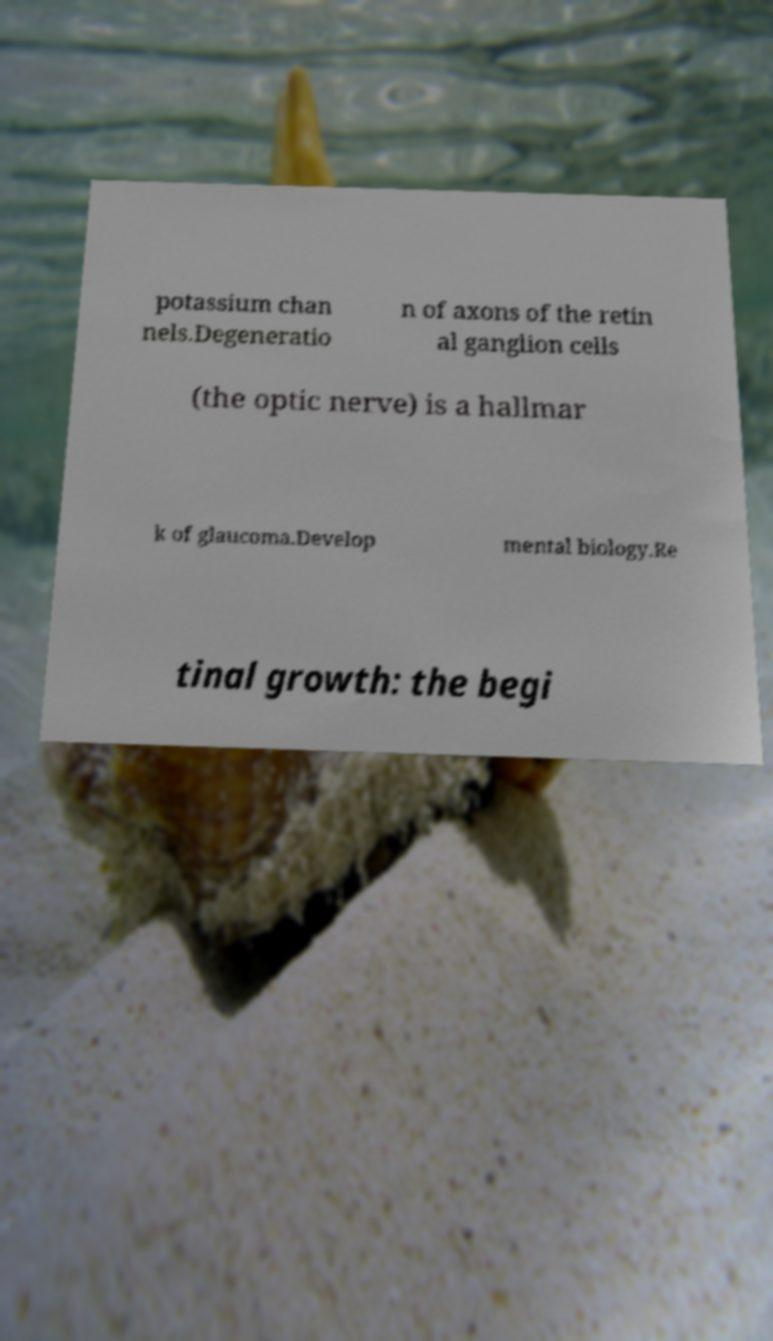For documentation purposes, I need the text within this image transcribed. Could you provide that? potassium chan nels.Degeneratio n of axons of the retin al ganglion cells (the optic nerve) is a hallmar k of glaucoma.Develop mental biology.Re tinal growth: the begi 